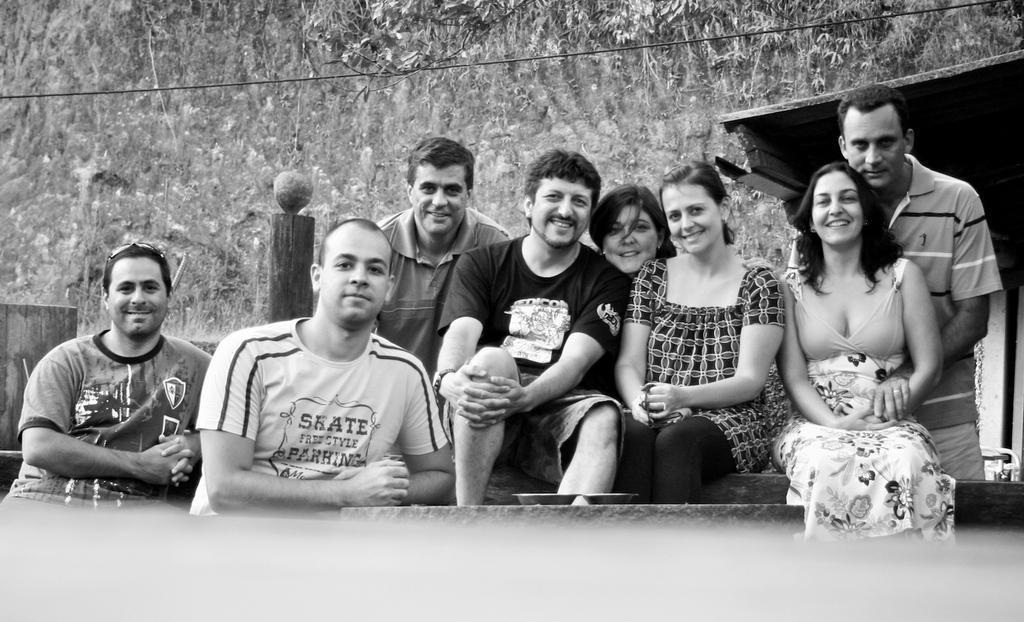How would you summarize this image in a sentence or two? In this picture we can see group of people, few are seated and few are standing, in front of them we can see a cable, and it is a black and white photograph, in the background we can find few plants. 